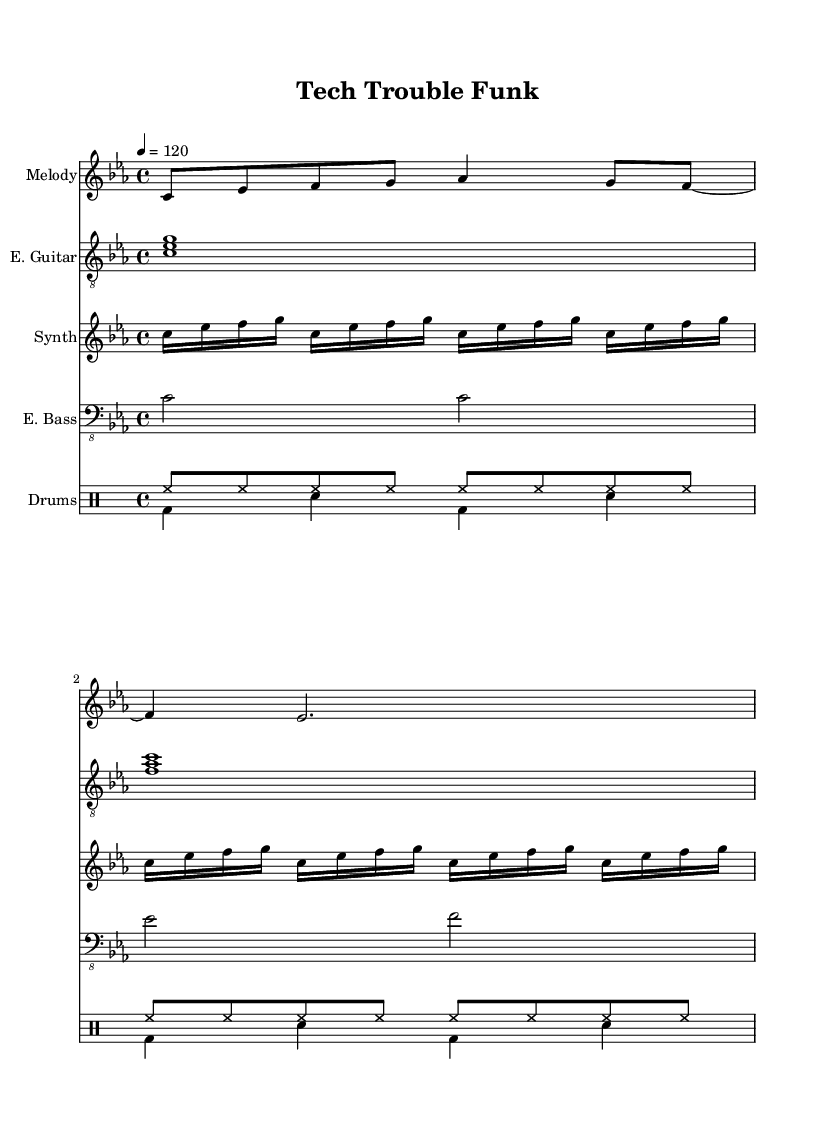What is the key signature of this music? The key signature is C minor, which has three flats: B flat, E flat, and A flat. This can be identified by the key signature markings at the beginning of the staff lines.
Answer: C minor What is the time signature of this music? The time signature is indicated at the beginning of the piece, showing a 4/4 on the top of the staff. This means there are four beats in each measure, and the quarter note gets one beat.
Answer: 4/4 What is the tempo marking of this music? The tempo is noted as 4 equals 120, indicating that there are 120 beats per minute, and this translates to a moderately fast pace typical in funk music. This is found at the beginning of the score.
Answer: 120 How many instruments are featured in this piece? The score contains four distinct staves for different instruments along with a drum staff: Melody, Electric Guitar, Synthesizer, Electric Bass, and the Drums which can be counted as one. This includes various vocal and instrumental arrangements.
Answer: Five Which rhythmic pattern is dominant in the drum part? The dominant rhythmic pattern in the drums is a repeating pattern of bass drum followed by snare drum, which creates a consistent groove typical in funk. Analyzing the drum part, the pattern bd4 sn bd sn repeats throughout the section.
Answer: Bass-snare Which genre does this piece belong to? The piece is classified as Funk music. This is evident from the rhythmic complexity, syncopation, and use of patterns typical of funk, as well as the overall upbeat and danceable feel that the instrumentation conveys.
Answer: Funk 